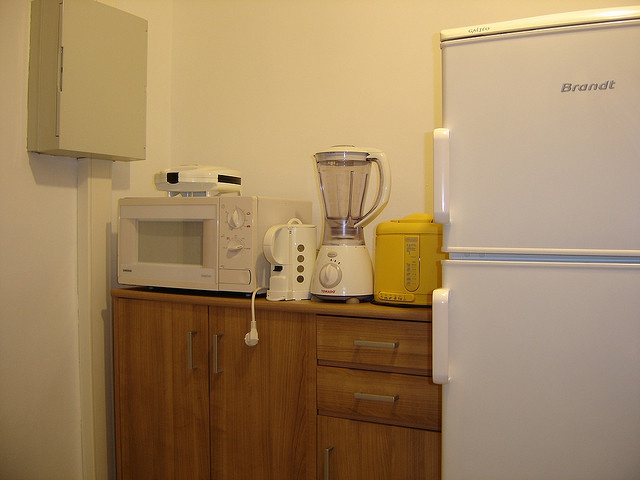Describe the objects in this image and their specific colors. I can see refrigerator in tan, darkgray, and gray tones and microwave in tan and gray tones in this image. 